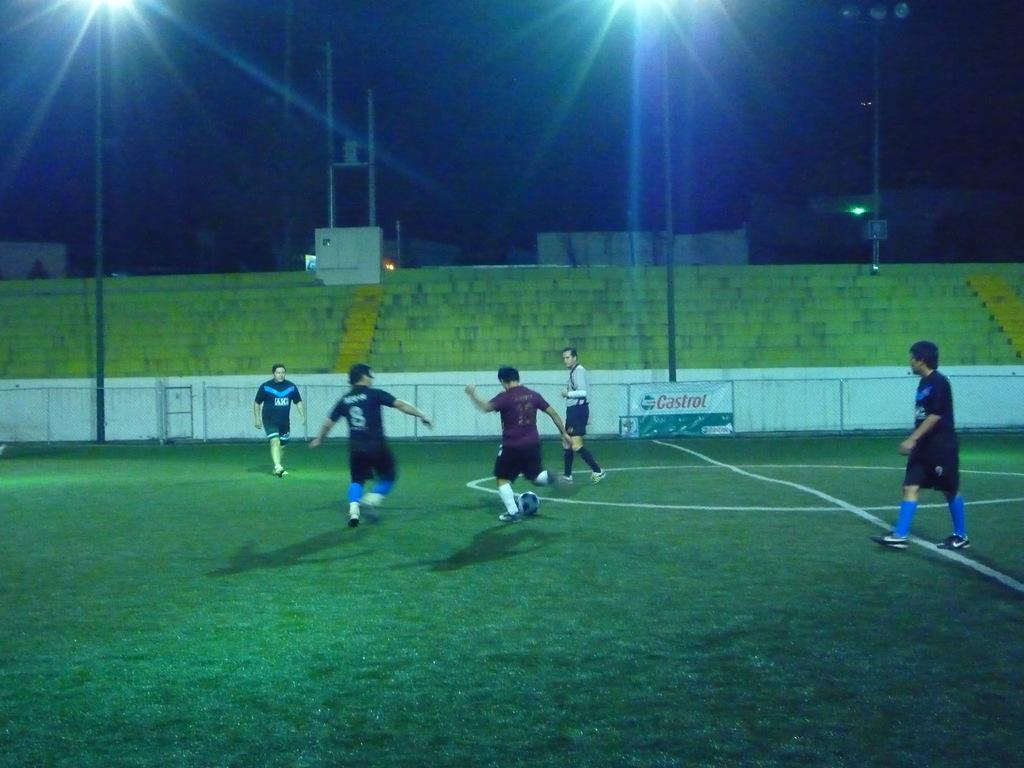Provide a one-sentence caption for the provided image. A group of guys on a soccer field in the night with a Castrol oil banner on the wall. 